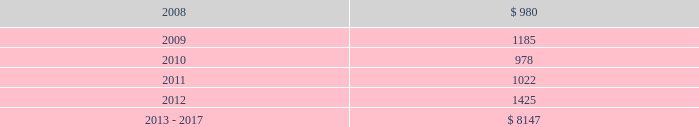Projected payments relating to these liabilities for the next five years ending december 31 , 2012 and the period from 2013 to 2017 are as follows ( in thousands ) : .
( 18 ) concentration of risk the company generates a significant amount of revenue from large customers , however , no customers accounted for more than 10% ( 10 % ) of total revenue or total segment revenue in the years ended december 31 , 2007 , 2006 and 2005 .
Financial instruments that potentially subject the company to concentrations of credit risk consist primarily of cash equivalents and trade receivables .
The company places its cash equivalents with high credit quality financial institutions and , by policy , limits the amount of credit exposure with any one financial institution .
Concentrations of credit risk with respect to trade receivables are limited because a large number of geographically diverse customers make up the company 2019s customer base , thus spreading the trade receivables credit risk .
The company controls credit risk through monitoring procedures .
( 19 ) segment information upon completion of the certegy merger , the company implemented a new organizational structure , which resulted in a new operating segment structure beginning with the reporting of first quarter 2006 results .
Effective as of february 1 , 2006 , the company 2019s operating segments are tps and lps .
This structure reflects how the businesses are operated and managed .
The primary components of the tps segment , which includes certegy 2019s card and check services , the financial institution processing component of the former financial institution software and services segment of fis and the operations acquired from efunds , are enterprise solutions , integrated financial solutions and international businesses .
The primary components of the lps segment are mortgage information services businesses , which includes the mortgage lender processing component of the former financial institution software and services segment of fis , and the former lender services , default management , and information services segments of fis .
Fidelity national information services , inc .
And subsidiaries and affiliates notes to consolidated and combined financial statements 2014 ( continued ) .
What is the growth rate in projected payments from 2008 to 2009? 
Computations: ((1185 - 980) / 980)
Answer: 0.20918. 